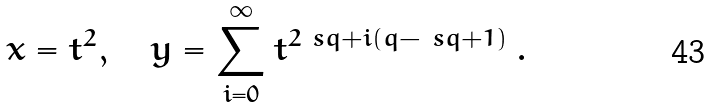Convert formula to latex. <formula><loc_0><loc_0><loc_500><loc_500>x = t ^ { 2 } , \quad y = \sum _ { i = 0 } ^ { \infty } t ^ { 2 \ s q + i ( q - \ s q + 1 ) } \, .</formula> 